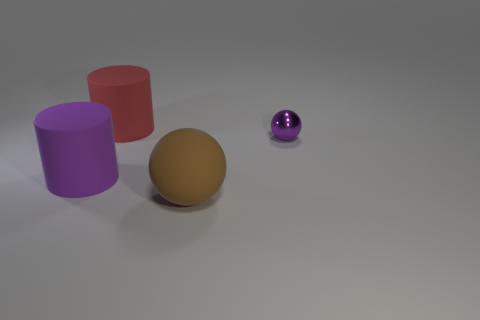Are there any other things that have the same material as the small purple ball?
Provide a succinct answer. No. Is there any other thing that has the same size as the metallic thing?
Make the answer very short. No. The other big cylinder that is made of the same material as the red cylinder is what color?
Your response must be concise. Purple. There is a ball that is in front of the small purple ball; is it the same color as the sphere on the right side of the matte sphere?
Your answer should be very brief. No. How many balls are either tiny shiny things or purple rubber objects?
Provide a short and direct response. 1. Is the number of red things to the right of the brown rubber ball the same as the number of purple objects?
Offer a very short reply. No. What material is the big cylinder behind the large rubber cylinder that is in front of the tiny purple metallic sphere to the right of the big brown matte thing made of?
Keep it short and to the point. Rubber. There is a large cylinder that is the same color as the metal ball; what material is it?
Your answer should be very brief. Rubber. What number of objects are either matte objects to the right of the red cylinder or purple matte spheres?
Provide a succinct answer. 1. How many things are either purple metallic objects or purple objects that are on the left side of the brown thing?
Ensure brevity in your answer.  2. 